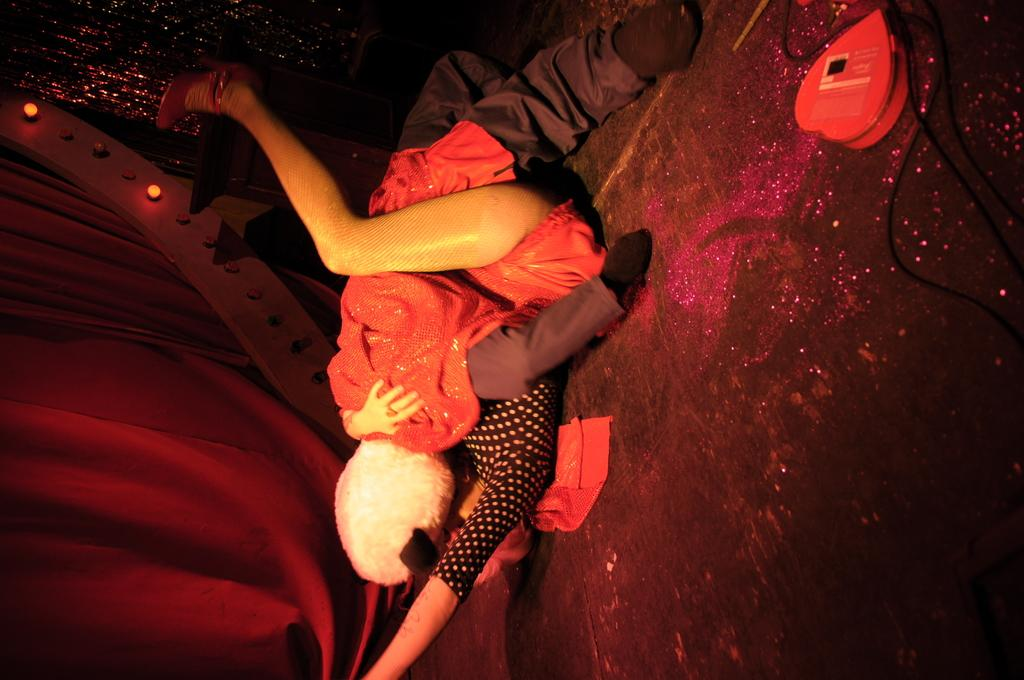What is on the floor in the image? There is a toy on the floor in the image, and a person is also on the floor. What else can be seen on the floor in the image? There are objects on the floor in the image. What is on the left side of the image? There are curtains on the left side of the image, and there are lights on an object on the left side of the image. How does the person in the image jump over the bottle? There is no bottle present in the image, so the person cannot jump over it. 